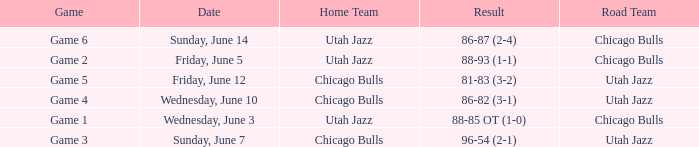Write the full table. {'header': ['Game', 'Date', 'Home Team', 'Result', 'Road Team'], 'rows': [['Game 6', 'Sunday, June 14', 'Utah Jazz', '86-87 (2-4)', 'Chicago Bulls'], ['Game 2', 'Friday, June 5', 'Utah Jazz', '88-93 (1-1)', 'Chicago Bulls'], ['Game 5', 'Friday, June 12', 'Chicago Bulls', '81-83 (3-2)', 'Utah Jazz'], ['Game 4', 'Wednesday, June 10', 'Chicago Bulls', '86-82 (3-1)', 'Utah Jazz'], ['Game 1', 'Wednesday, June 3', 'Utah Jazz', '88-85 OT (1-0)', 'Chicago Bulls'], ['Game 3', 'Sunday, June 7', 'Chicago Bulls', '96-54 (2-1)', 'Utah Jazz']]} Home Team of chicago bulls, and a Result of 81-83 (3-2) involved what game? Game 5. 